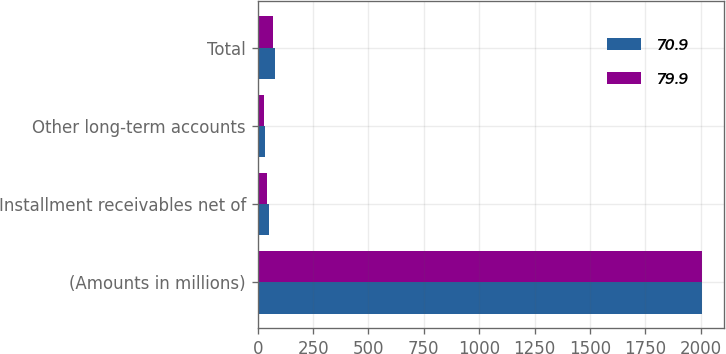Convert chart. <chart><loc_0><loc_0><loc_500><loc_500><stacked_bar_chart><ecel><fcel>(Amounts in millions)<fcel>Installment receivables net of<fcel>Other long-term accounts<fcel>Total<nl><fcel>70.9<fcel>2007<fcel>49.2<fcel>30.7<fcel>79.9<nl><fcel>79.9<fcel>2006<fcel>42.6<fcel>28.3<fcel>70.9<nl></chart> 